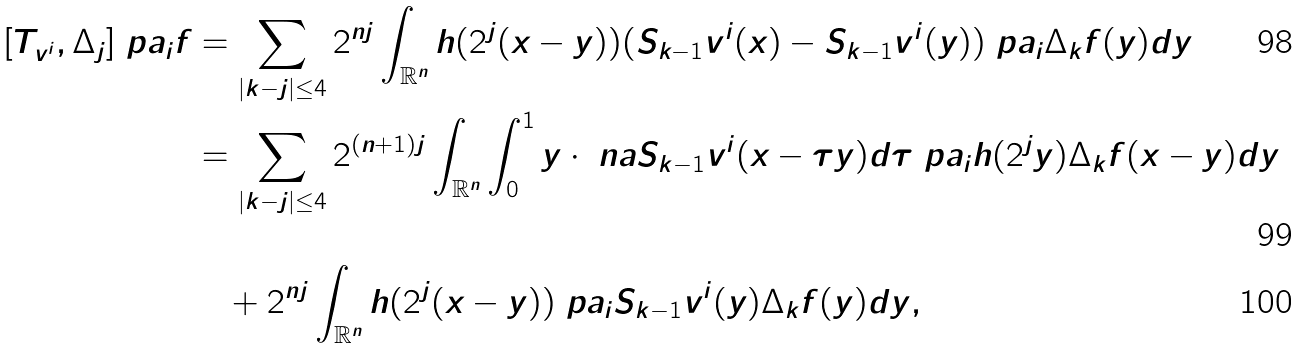<formula> <loc_0><loc_0><loc_500><loc_500>[ T _ { v ^ { i } } , \Delta _ { j } ] \ p a _ { i } f & = \sum _ { | k - j | \leq 4 } 2 ^ { n j } \int _ { \mathbb { R } ^ { n } } h ( 2 ^ { j } ( x - y ) ) ( S _ { k - 1 } v ^ { i } ( x ) - S _ { k - 1 } v ^ { i } ( y ) ) \ p a _ { i } \Delta _ { k } f ( y ) d y \\ & = \sum _ { | k - j | \leq 4 } 2 ^ { ( n + 1 ) j } \int _ { \mathbb { R } ^ { n } } \int _ { 0 } ^ { 1 } y \cdot \ n a S _ { k - 1 } v ^ { i } ( x - \tau y ) d \tau \ p a _ { i } h ( 2 ^ { j } y ) \Delta _ { k } f ( x - y ) d y \\ & \quad + 2 ^ { n j } \int _ { \mathbb { R } ^ { n } } h ( 2 ^ { j } ( x - y ) ) \ p a _ { i } S _ { k - 1 } v ^ { i } ( y ) \Delta _ { k } f ( y ) d y ,</formula> 